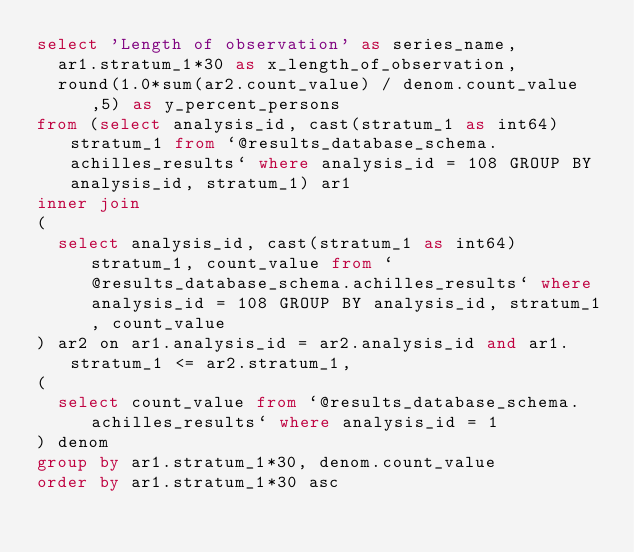Convert code to text. <code><loc_0><loc_0><loc_500><loc_500><_SQL_>select 'Length of observation' as series_name, 
	ar1.stratum_1*30 as x_length_of_observation, 
	round(1.0*sum(ar2.count_value) / denom.count_value,5) as y_percent_persons
from (select analysis_id, cast(stratum_1 as int64) stratum_1 from `@results_database_schema.achilles_results` where analysis_id = 108 GROUP BY analysis_id, stratum_1) ar1
inner join
(
	select analysis_id, cast(stratum_1 as int64) stratum_1, count_value from `@results_database_schema.achilles_results` where analysis_id = 108 GROUP BY analysis_id, stratum_1, count_value
) ar2 on ar1.analysis_id = ar2.analysis_id and ar1.stratum_1 <= ar2.stratum_1,
(
	select count_value from `@results_database_schema.achilles_results` where analysis_id = 1
) denom
group by ar1.stratum_1*30, denom.count_value
order by ar1.stratum_1*30 asc
</code> 